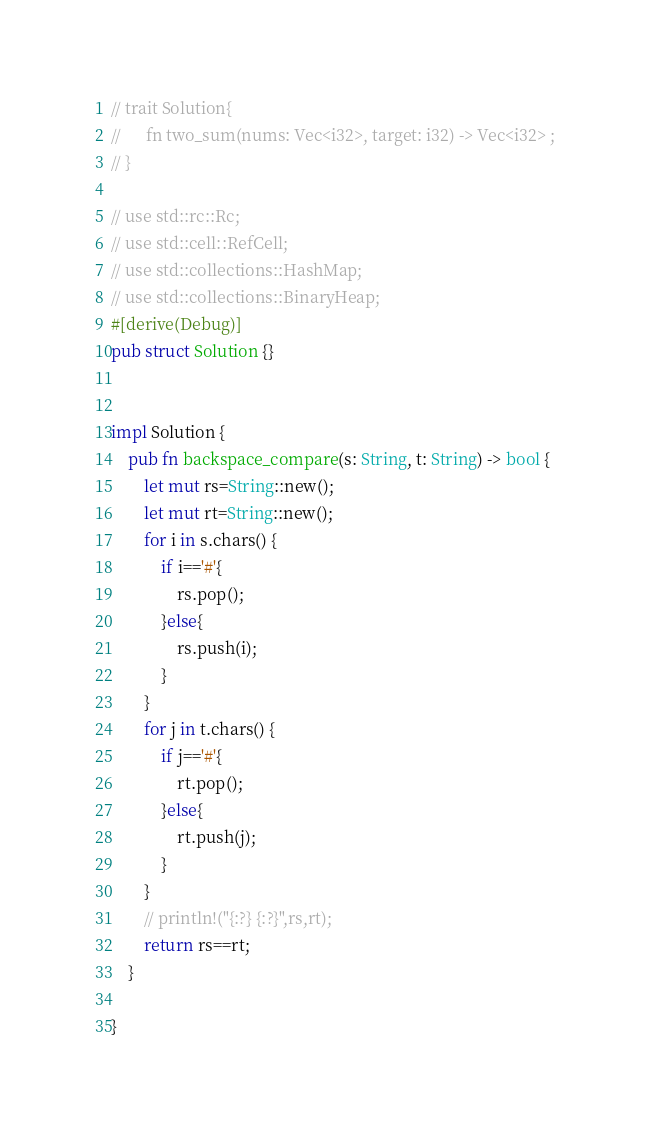Convert code to text. <code><loc_0><loc_0><loc_500><loc_500><_Rust_>// trait Solution{
//      fn two_sum(nums: Vec<i32>, target: i32) -> Vec<i32> ;
// }

// use std::rc::Rc;
// use std::cell::RefCell;
// use std::collections::HashMap;
// use std::collections::BinaryHeap;
#[derive(Debug)]
pub struct Solution {}


impl Solution {
    pub fn backspace_compare(s: String, t: String) -> bool {
        let mut rs=String::new();
        let mut rt=String::new();
        for i in s.chars() {
            if i=='#'{
                rs.pop();
            }else{
                rs.push(i);
            }
        }
        for j in t.chars() {
            if j=='#'{
                rt.pop();
            }else{
                rt.push(j);
            }
        }
        // println!("{:?} {:?}",rs,rt);
        return rs==rt;
    }

}
</code> 